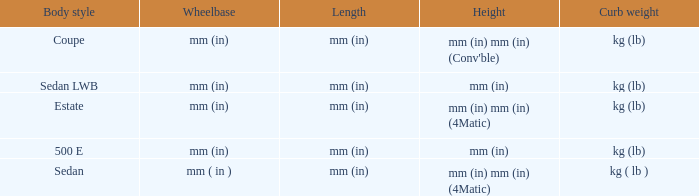What are the lengths of the models that are mm (in) tall? Mm (in), mm (in). 